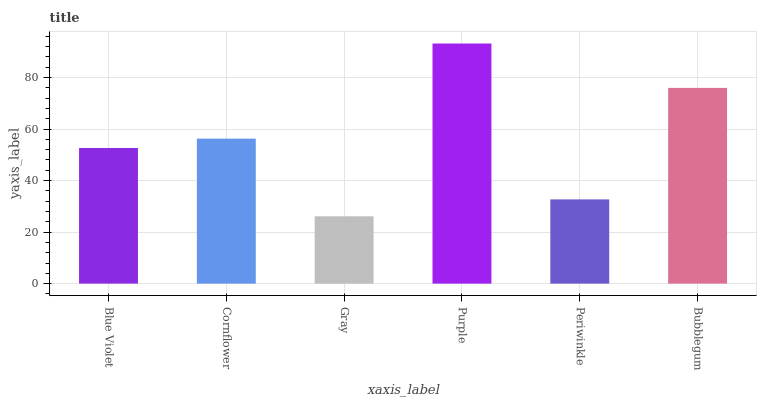Is Gray the minimum?
Answer yes or no. Yes. Is Purple the maximum?
Answer yes or no. Yes. Is Cornflower the minimum?
Answer yes or no. No. Is Cornflower the maximum?
Answer yes or no. No. Is Cornflower greater than Blue Violet?
Answer yes or no. Yes. Is Blue Violet less than Cornflower?
Answer yes or no. Yes. Is Blue Violet greater than Cornflower?
Answer yes or no. No. Is Cornflower less than Blue Violet?
Answer yes or no. No. Is Cornflower the high median?
Answer yes or no. Yes. Is Blue Violet the low median?
Answer yes or no. Yes. Is Purple the high median?
Answer yes or no. No. Is Cornflower the low median?
Answer yes or no. No. 